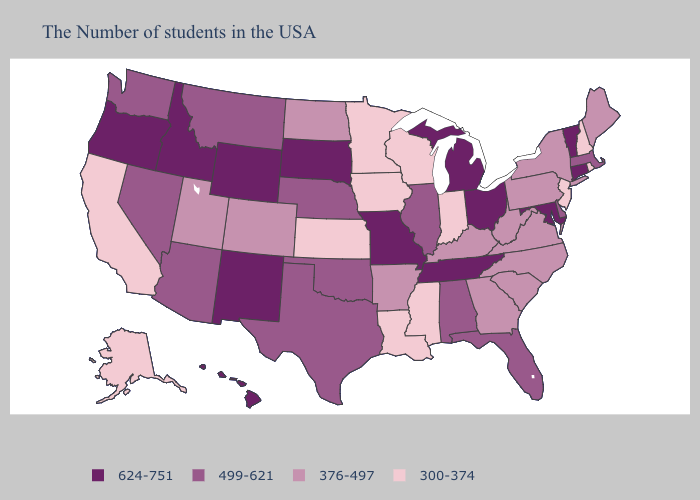Does the map have missing data?
Answer briefly. No. Does Idaho have the lowest value in the USA?
Keep it brief. No. Does Kentucky have the highest value in the South?
Keep it brief. No. Does the map have missing data?
Write a very short answer. No. Is the legend a continuous bar?
Give a very brief answer. No. Among the states that border Delaware , does Maryland have the highest value?
Answer briefly. Yes. Which states hav the highest value in the MidWest?
Quick response, please. Ohio, Michigan, Missouri, South Dakota. Name the states that have a value in the range 300-374?
Give a very brief answer. Rhode Island, New Hampshire, New Jersey, Indiana, Wisconsin, Mississippi, Louisiana, Minnesota, Iowa, Kansas, California, Alaska. What is the value of Vermont?
Concise answer only. 624-751. Does the first symbol in the legend represent the smallest category?
Keep it brief. No. Among the states that border Massachusetts , does Vermont have the highest value?
Answer briefly. Yes. Which states have the lowest value in the USA?
Keep it brief. Rhode Island, New Hampshire, New Jersey, Indiana, Wisconsin, Mississippi, Louisiana, Minnesota, Iowa, Kansas, California, Alaska. What is the value of Minnesota?
Answer briefly. 300-374. Among the states that border West Virginia , which have the lowest value?
Short answer required. Pennsylvania, Virginia, Kentucky. 